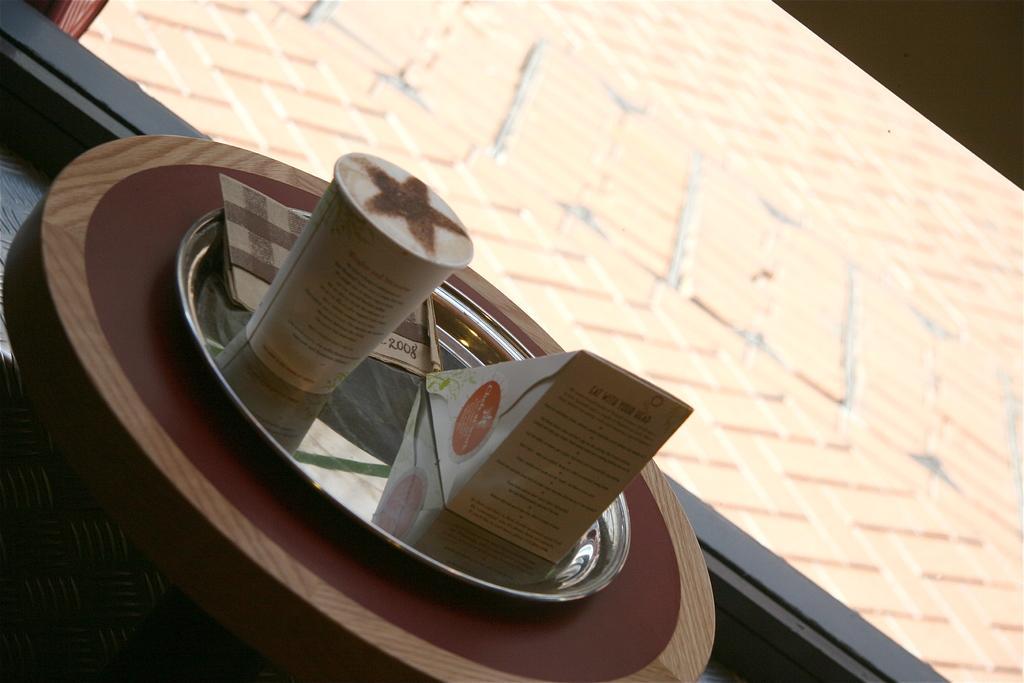In one or two sentences, can you explain what this image depicts? In this picture, we can see some objects on the plate like, a cup with some liquid in it, we can see wooden object with a plate is rested on the black surface, we can see the ground. 